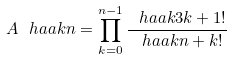<formula> <loc_0><loc_0><loc_500><loc_500>A \ h a a k { n } = \prod _ { k = 0 } ^ { n - 1 } \frac { \ h a a k { 3 k + 1 } ! } { \ h a a k { n + k } ! }</formula> 